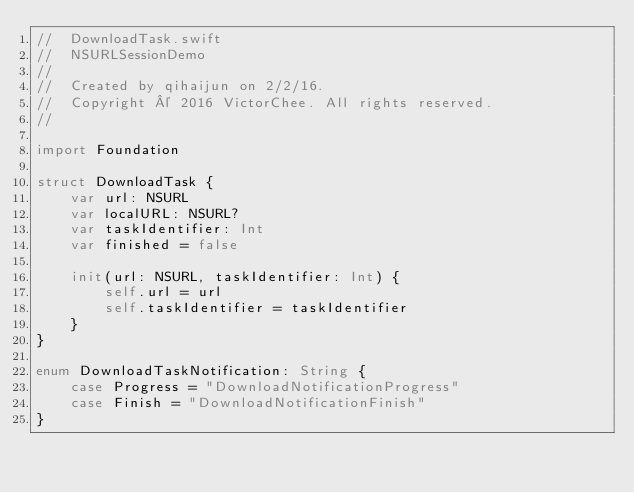<code> <loc_0><loc_0><loc_500><loc_500><_Swift_>//  DownloadTask.swift
//  NSURLSessionDemo
//
//  Created by qihaijun on 2/2/16.
//  Copyright © 2016 VictorChee. All rights reserved.
//

import Foundation

struct DownloadTask {
    var url: NSURL
    var localURL: NSURL?
    var taskIdentifier: Int
    var finished = false
    
    init(url: NSURL, taskIdentifier: Int) {
        self.url = url
        self.taskIdentifier = taskIdentifier
    }
}

enum DownloadTaskNotification: String {
    case Progress = "DownloadNotificationProgress"
    case Finish = "DownloadNotificationFinish"
}</code> 